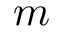<formula> <loc_0><loc_0><loc_500><loc_500>m</formula> 